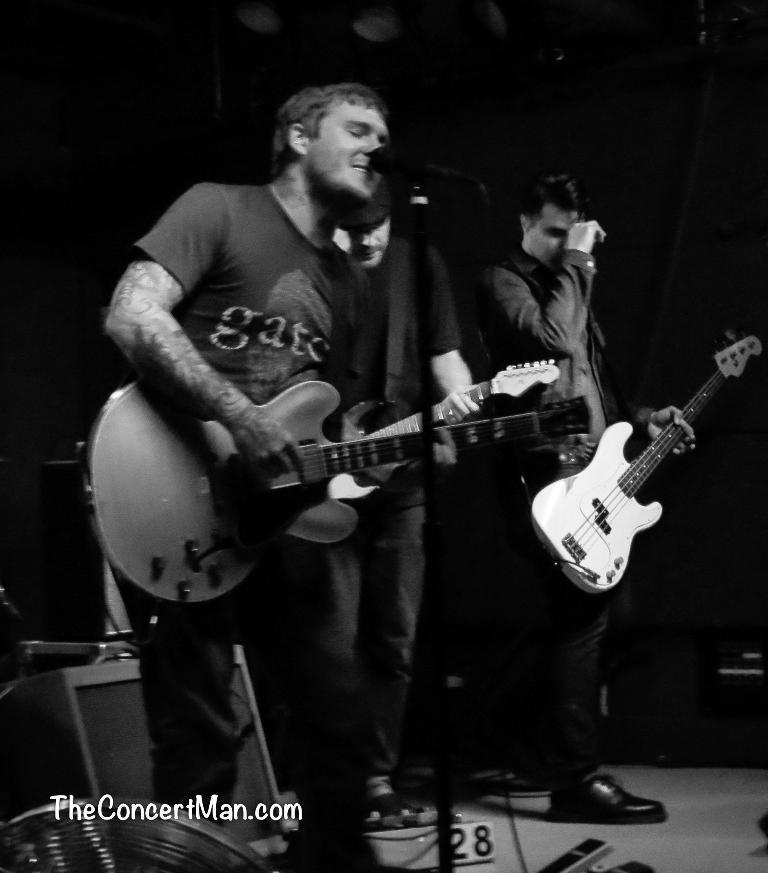What is the man in the image doing? The man is playing the guitar and singing a song. What instrument is the man playing in the image? The man is playing the guitar. What activity is the man engaged in while playing the guitar? The man is singing a song. What color is the orange the man is holding in the image? There is no orange present in the image; the man is playing the guitar and singing a song. 